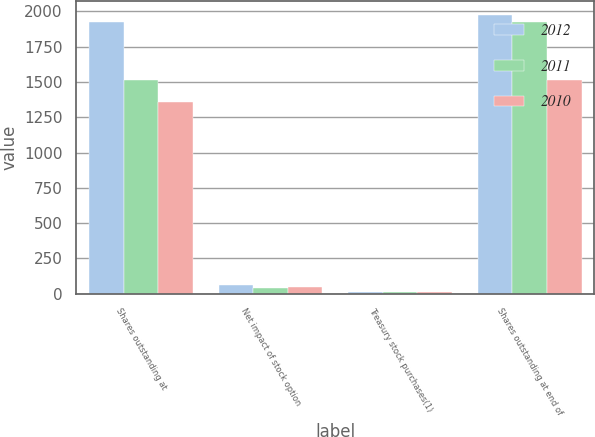<chart> <loc_0><loc_0><loc_500><loc_500><stacked_bar_chart><ecel><fcel>Shares outstanding at<fcel>Net impact of stock option<fcel>Treasury stock purchases(1)<fcel>Shares outstanding at end of<nl><fcel>2012<fcel>1927<fcel>60<fcel>13<fcel>1974<nl><fcel>2011<fcel>1512<fcel>41<fcel>11<fcel>1927<nl><fcel>2010<fcel>1361<fcel>46<fcel>11<fcel>1512<nl></chart> 